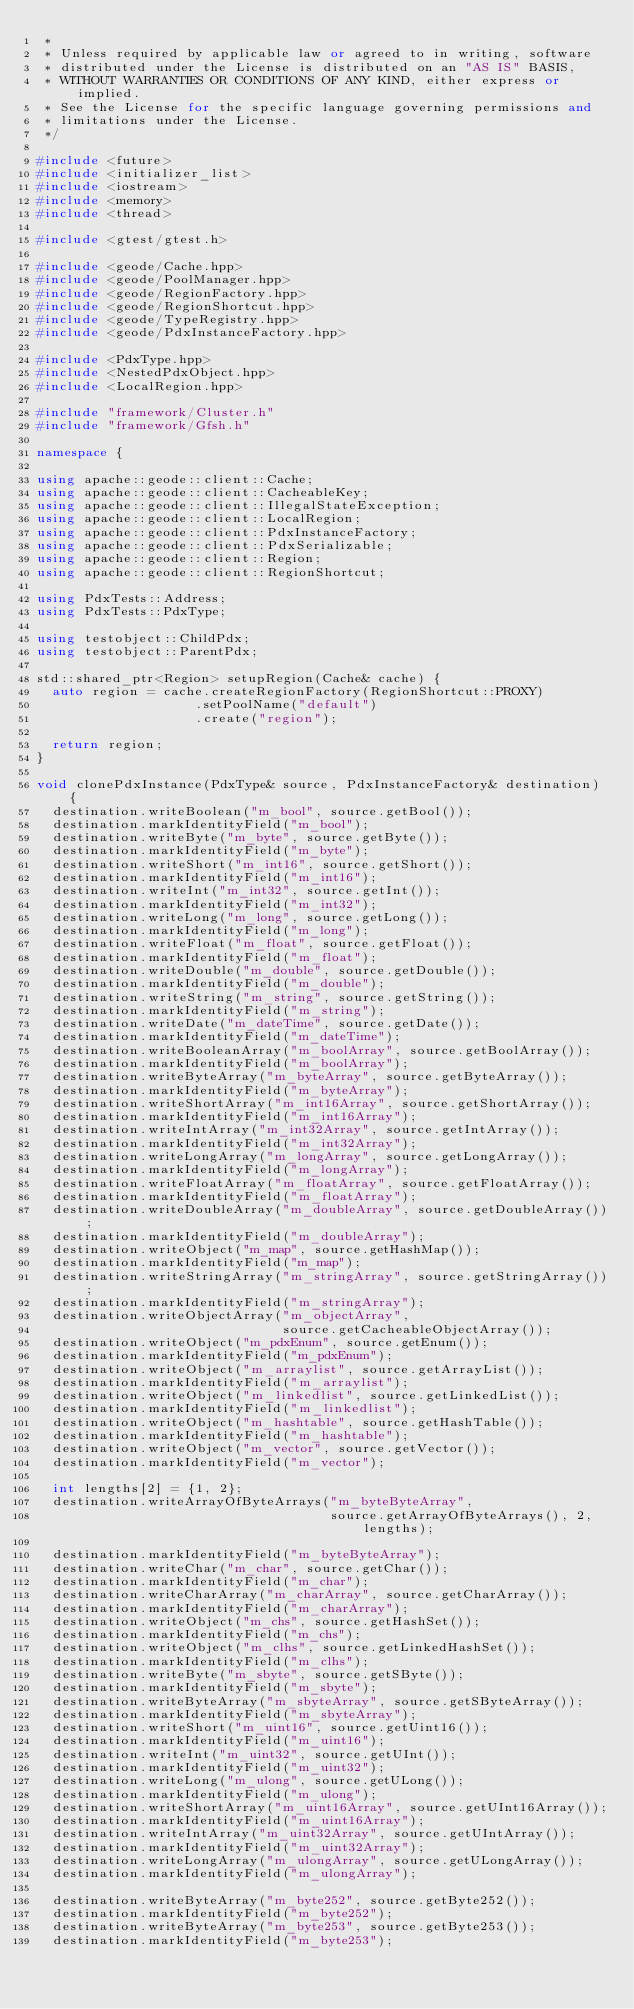Convert code to text. <code><loc_0><loc_0><loc_500><loc_500><_C++_> *
 * Unless required by applicable law or agreed to in writing, software
 * distributed under the License is distributed on an "AS IS" BASIS,
 * WITHOUT WARRANTIES OR CONDITIONS OF ANY KIND, either express or implied.
 * See the License for the specific language governing permissions and
 * limitations under the License.
 */

#include <future>
#include <initializer_list>
#include <iostream>
#include <memory>
#include <thread>

#include <gtest/gtest.h>

#include <geode/Cache.hpp>
#include <geode/PoolManager.hpp>
#include <geode/RegionFactory.hpp>
#include <geode/RegionShortcut.hpp>
#include <geode/TypeRegistry.hpp>
#include <geode/PdxInstanceFactory.hpp>

#include <PdxType.hpp>
#include <NestedPdxObject.hpp>
#include <LocalRegion.hpp>

#include "framework/Cluster.h"
#include "framework/Gfsh.h"

namespace {

using apache::geode::client::Cache;
using apache::geode::client::CacheableKey;
using apache::geode::client::IllegalStateException;
using apache::geode::client::LocalRegion;
using apache::geode::client::PdxInstanceFactory;
using apache::geode::client::PdxSerializable;
using apache::geode::client::Region;
using apache::geode::client::RegionShortcut;

using PdxTests::Address;
using PdxTests::PdxType;

using testobject::ChildPdx;
using testobject::ParentPdx;

std::shared_ptr<Region> setupRegion(Cache& cache) {
  auto region = cache.createRegionFactory(RegionShortcut::PROXY)
                    .setPoolName("default")
                    .create("region");

  return region;
}

void clonePdxInstance(PdxType& source, PdxInstanceFactory& destination) {
  destination.writeBoolean("m_bool", source.getBool());
  destination.markIdentityField("m_bool");
  destination.writeByte("m_byte", source.getByte());
  destination.markIdentityField("m_byte");
  destination.writeShort("m_int16", source.getShort());
  destination.markIdentityField("m_int16");
  destination.writeInt("m_int32", source.getInt());
  destination.markIdentityField("m_int32");
  destination.writeLong("m_long", source.getLong());
  destination.markIdentityField("m_long");
  destination.writeFloat("m_float", source.getFloat());
  destination.markIdentityField("m_float");
  destination.writeDouble("m_double", source.getDouble());
  destination.markIdentityField("m_double");
  destination.writeString("m_string", source.getString());
  destination.markIdentityField("m_string");
  destination.writeDate("m_dateTime", source.getDate());
  destination.markIdentityField("m_dateTime");
  destination.writeBooleanArray("m_boolArray", source.getBoolArray());
  destination.markIdentityField("m_boolArray");
  destination.writeByteArray("m_byteArray", source.getByteArray());
  destination.markIdentityField("m_byteArray");
  destination.writeShortArray("m_int16Array", source.getShortArray());
  destination.markIdentityField("m_int16Array");
  destination.writeIntArray("m_int32Array", source.getIntArray());
  destination.markIdentityField("m_int32Array");
  destination.writeLongArray("m_longArray", source.getLongArray());
  destination.markIdentityField("m_longArray");
  destination.writeFloatArray("m_floatArray", source.getFloatArray());
  destination.markIdentityField("m_floatArray");
  destination.writeDoubleArray("m_doubleArray", source.getDoubleArray());
  destination.markIdentityField("m_doubleArray");
  destination.writeObject("m_map", source.getHashMap());
  destination.markIdentityField("m_map");
  destination.writeStringArray("m_stringArray", source.getStringArray());
  destination.markIdentityField("m_stringArray");
  destination.writeObjectArray("m_objectArray",
                               source.getCacheableObjectArray());
  destination.writeObject("m_pdxEnum", source.getEnum());
  destination.markIdentityField("m_pdxEnum");
  destination.writeObject("m_arraylist", source.getArrayList());
  destination.markIdentityField("m_arraylist");
  destination.writeObject("m_linkedlist", source.getLinkedList());
  destination.markIdentityField("m_linkedlist");
  destination.writeObject("m_hashtable", source.getHashTable());
  destination.markIdentityField("m_hashtable");
  destination.writeObject("m_vector", source.getVector());
  destination.markIdentityField("m_vector");

  int lengths[2] = {1, 2};
  destination.writeArrayOfByteArrays("m_byteByteArray",
                                     source.getArrayOfByteArrays(), 2, lengths);

  destination.markIdentityField("m_byteByteArray");
  destination.writeChar("m_char", source.getChar());
  destination.markIdentityField("m_char");
  destination.writeCharArray("m_charArray", source.getCharArray());
  destination.markIdentityField("m_charArray");
  destination.writeObject("m_chs", source.getHashSet());
  destination.markIdentityField("m_chs");
  destination.writeObject("m_clhs", source.getLinkedHashSet());
  destination.markIdentityField("m_clhs");
  destination.writeByte("m_sbyte", source.getSByte());
  destination.markIdentityField("m_sbyte");
  destination.writeByteArray("m_sbyteArray", source.getSByteArray());
  destination.markIdentityField("m_sbyteArray");
  destination.writeShort("m_uint16", source.getUint16());
  destination.markIdentityField("m_uint16");
  destination.writeInt("m_uint32", source.getUInt());
  destination.markIdentityField("m_uint32");
  destination.writeLong("m_ulong", source.getULong());
  destination.markIdentityField("m_ulong");
  destination.writeShortArray("m_uint16Array", source.getUInt16Array());
  destination.markIdentityField("m_uint16Array");
  destination.writeIntArray("m_uint32Array", source.getUIntArray());
  destination.markIdentityField("m_uint32Array");
  destination.writeLongArray("m_ulongArray", source.getULongArray());
  destination.markIdentityField("m_ulongArray");

  destination.writeByteArray("m_byte252", source.getByte252());
  destination.markIdentityField("m_byte252");
  destination.writeByteArray("m_byte253", source.getByte253());
  destination.markIdentityField("m_byte253");</code> 